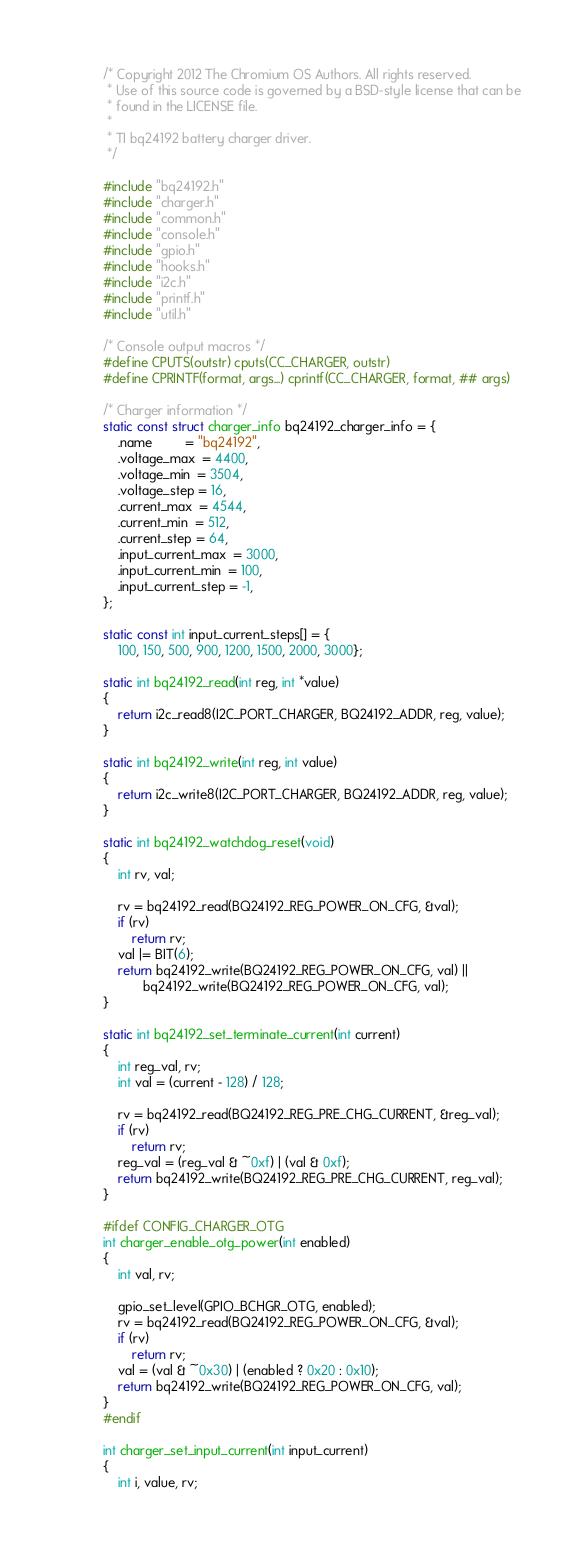Convert code to text. <code><loc_0><loc_0><loc_500><loc_500><_C_>/* Copyright 2012 The Chromium OS Authors. All rights reserved.
 * Use of this source code is governed by a BSD-style license that can be
 * found in the LICENSE file.
 *
 * TI bq24192 battery charger driver.
 */

#include "bq24192.h"
#include "charger.h"
#include "common.h"
#include "console.h"
#include "gpio.h"
#include "hooks.h"
#include "i2c.h"
#include "printf.h"
#include "util.h"

/* Console output macros */
#define CPUTS(outstr) cputs(CC_CHARGER, outstr)
#define CPRINTF(format, args...) cprintf(CC_CHARGER, format, ## args)

/* Charger information */
static const struct charger_info bq24192_charger_info = {
	.name         = "bq24192",
	.voltage_max  = 4400,
	.voltage_min  = 3504,
	.voltage_step = 16,
	.current_max  = 4544,
	.current_min  = 512,
	.current_step = 64,
	.input_current_max  = 3000,
	.input_current_min  = 100,
	.input_current_step = -1,
};

static const int input_current_steps[] = {
	100, 150, 500, 900, 1200, 1500, 2000, 3000};

static int bq24192_read(int reg, int *value)
{
	return i2c_read8(I2C_PORT_CHARGER, BQ24192_ADDR, reg, value);
}

static int bq24192_write(int reg, int value)
{
	return i2c_write8(I2C_PORT_CHARGER, BQ24192_ADDR, reg, value);
}

static int bq24192_watchdog_reset(void)
{
	int rv, val;

	rv = bq24192_read(BQ24192_REG_POWER_ON_CFG, &val);
	if (rv)
		return rv;
	val |= BIT(6);
	return bq24192_write(BQ24192_REG_POWER_ON_CFG, val) ||
	       bq24192_write(BQ24192_REG_POWER_ON_CFG, val);
}

static int bq24192_set_terminate_current(int current)
{
	int reg_val, rv;
	int val = (current - 128) / 128;

	rv = bq24192_read(BQ24192_REG_PRE_CHG_CURRENT, &reg_val);
	if (rv)
		return rv;
	reg_val = (reg_val & ~0xf) | (val & 0xf);
	return bq24192_write(BQ24192_REG_PRE_CHG_CURRENT, reg_val);
}

#ifdef CONFIG_CHARGER_OTG
int charger_enable_otg_power(int enabled)
{
	int val, rv;

	gpio_set_level(GPIO_BCHGR_OTG, enabled);
	rv = bq24192_read(BQ24192_REG_POWER_ON_CFG, &val);
	if (rv)
		return rv;
	val = (val & ~0x30) | (enabled ? 0x20 : 0x10);
	return bq24192_write(BQ24192_REG_POWER_ON_CFG, val);
}
#endif

int charger_set_input_current(int input_current)
{
	int i, value, rv;
</code> 